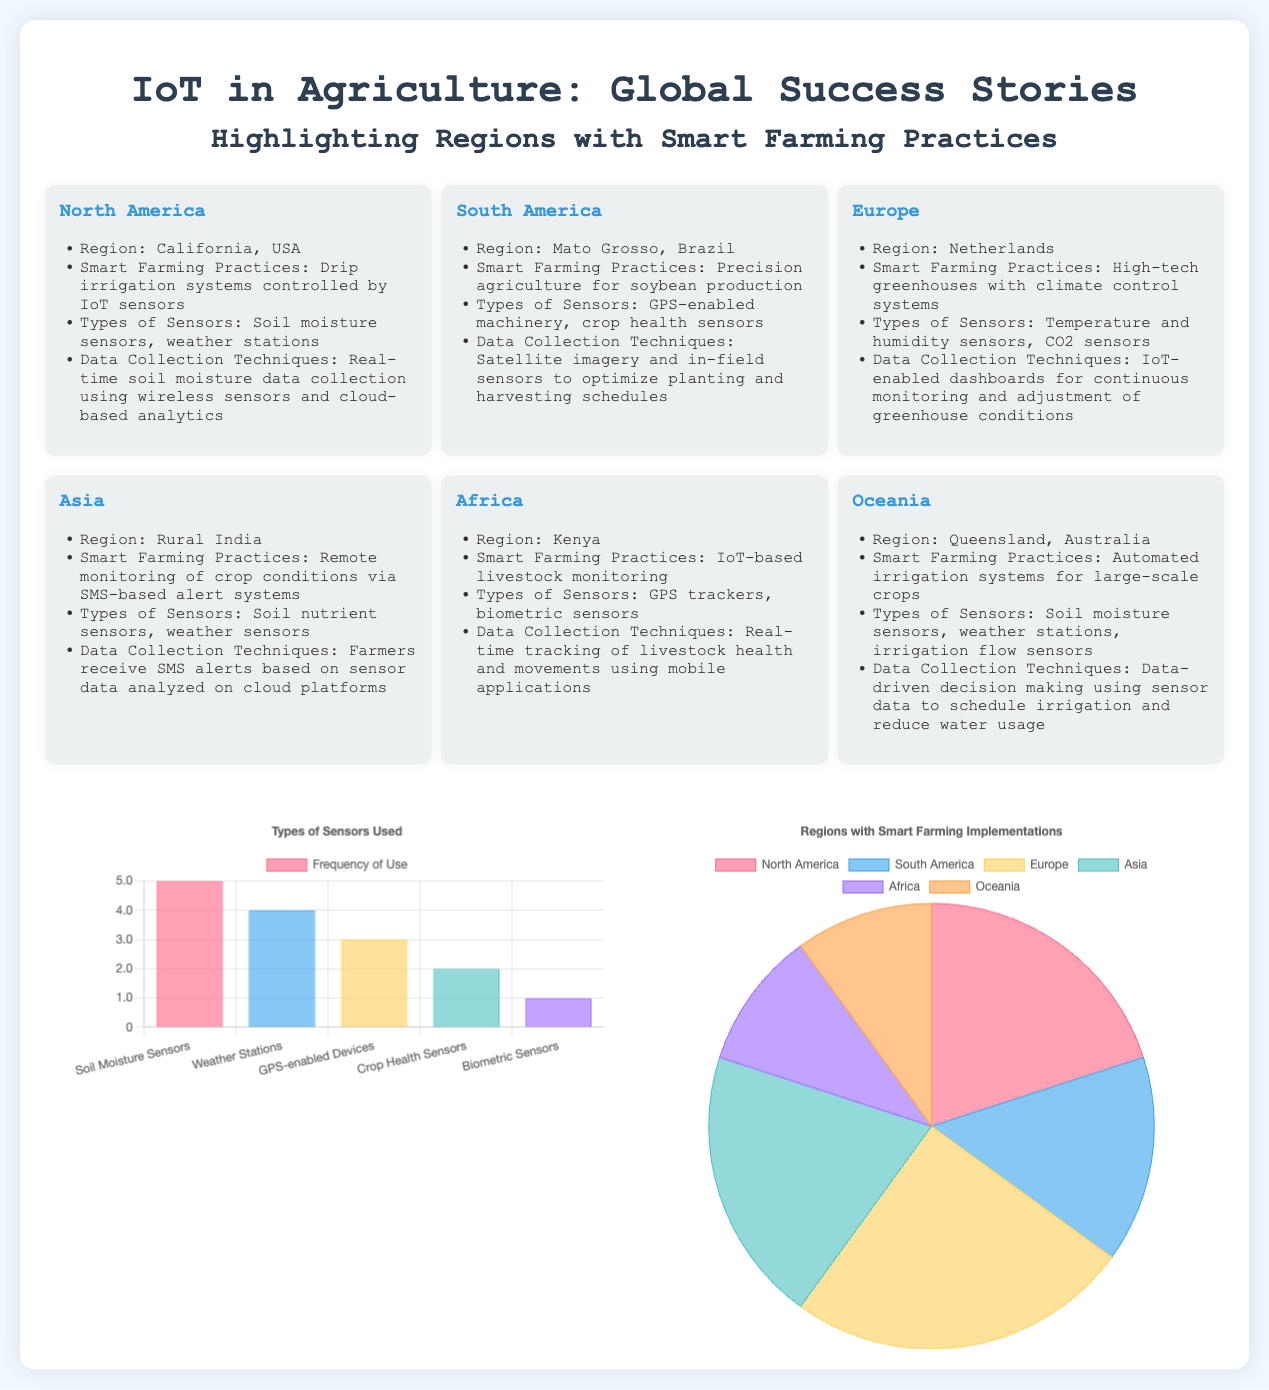What region is highlighted for smart farming practices in Europe? The region highlighted for smart farming practices in Europe is the Netherlands.
Answer: Netherlands What types of sensors are used in North America? The types of sensors used in North America include soil moisture sensors and weather stations.
Answer: Soil moisture sensors, weather stations Which South American region practices precision agriculture? The region in South America that practices precision agriculture is Mato Grosso, Brazil.
Answer: Mato Grosso, Brazil How many types of sensors are mentioned in the bar chart? The bar chart lists five types of sensors used in agriculture.
Answer: 5 What is the primary smart farming practice in Africa? The primary smart farming practice in Africa is IoT-based livestock monitoring.
Answer: IoT-based livestock monitoring Which region has the highest percentage of smart farming implementations? The region with the highest percentage of smart farming implementations is Europe.
Answer: Europe What data collection technique is used in Rural India? The data collection technique used in Rural India is SMS-based alert systems.
Answer: SMS-based alert systems How many regions are highlighted in the infographic? The infographic highlights six regions.
Answer: 6 What is the focus of the pie chart in the document? The pie chart focuses on the regions with smart farming implementations.
Answer: Regions with smart farming implementations 